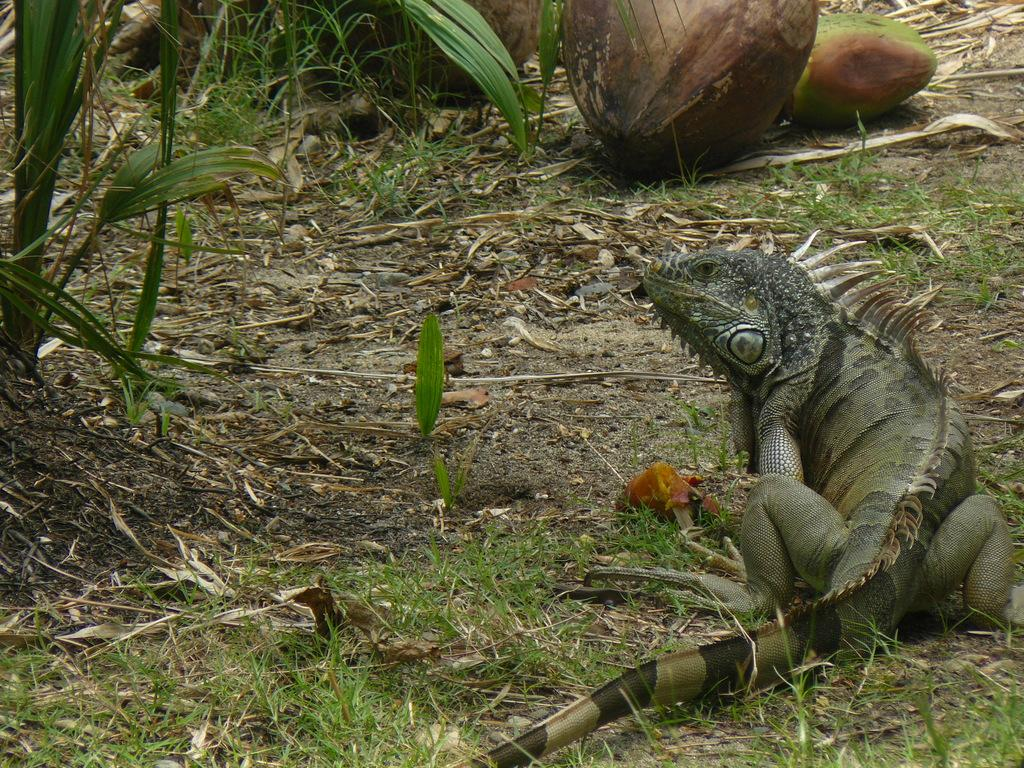What type of animal is in the image? There is an iguana in the image. Where is the iguana located? The iguana is on the grass. What objects are in front of the iguana? There are coconuts in front of the iguana. What can be seen on the left side of the image? There is a plant on the left side of the image. What type of marble is the iguana using to play with the yarn in the image? There is no marble or yarn present in the image, and therefore no such activity can be observed. 